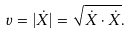Convert formula to latex. <formula><loc_0><loc_0><loc_500><loc_500>v = | { \dot { X } } | = { \sqrt { { \dot { X } } \cdot { \dot { X } } } } .</formula> 